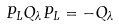Convert formula to latex. <formula><loc_0><loc_0><loc_500><loc_500>P _ { L } Q _ { \lambda } P _ { L } = - Q _ { \lambda }</formula> 